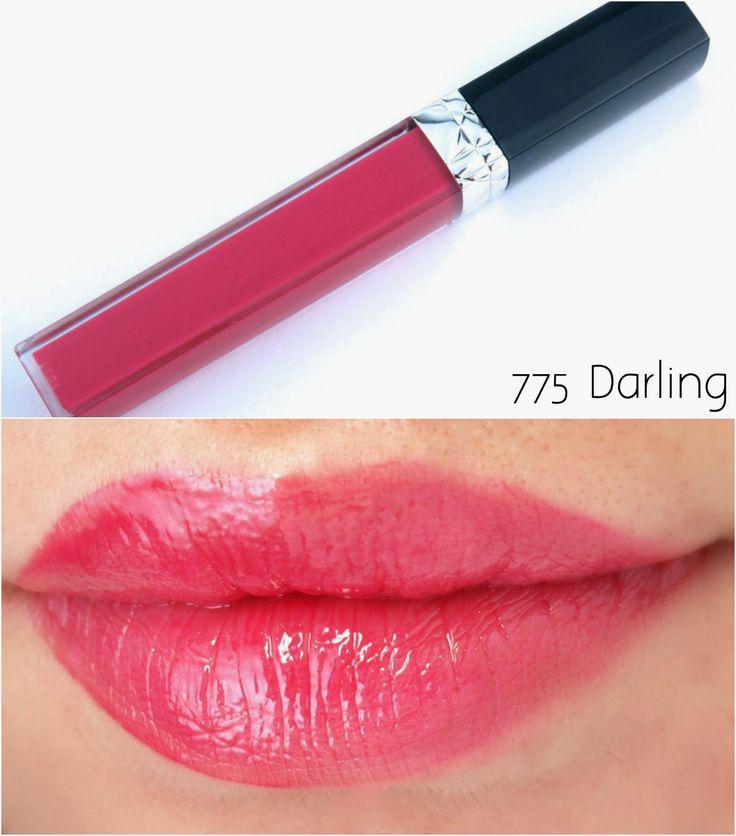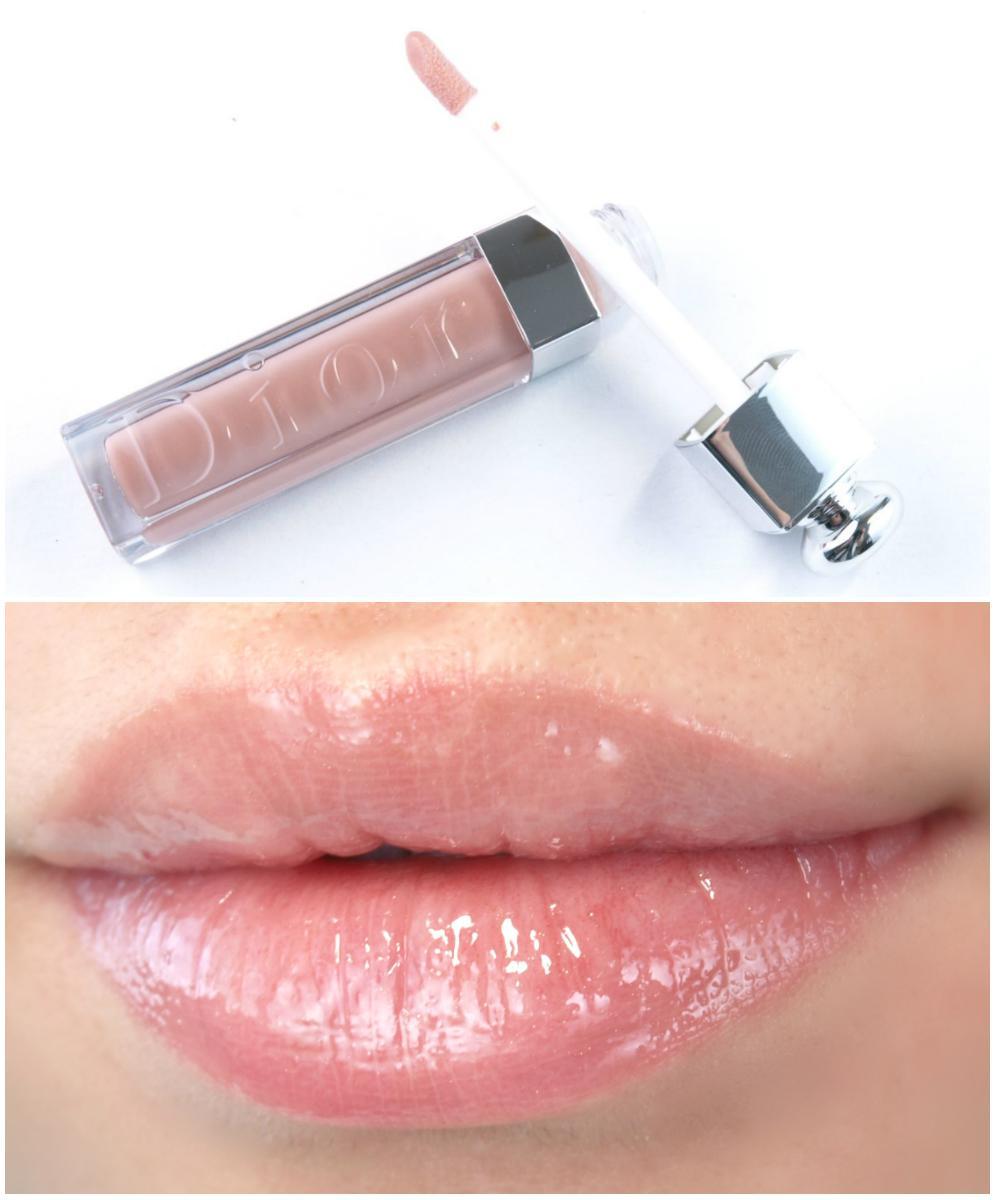The first image is the image on the left, the second image is the image on the right. Given the left and right images, does the statement "At least one of the images includes streaks of lip gloss on someone's skin." hold true? Answer yes or no. No. The first image is the image on the left, the second image is the image on the right. For the images displayed, is the sentence "Color swatches of lip products are on a person's skin." factually correct? Answer yes or no. No. 